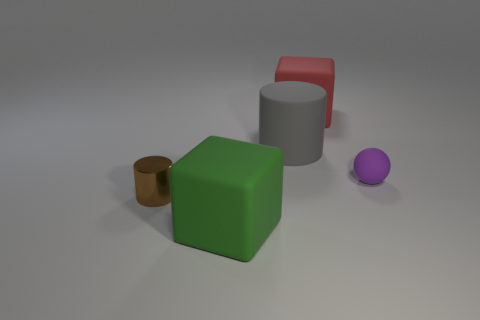Is there anything else that has the same shape as the tiny purple object?
Provide a short and direct response. No. The thing that is both on the right side of the brown object and in front of the tiny purple matte thing is what color?
Give a very brief answer. Green. How many tiny cubes are there?
Your response must be concise. 0. Does the metal object have the same size as the rubber ball?
Ensure brevity in your answer.  Yes. Do the tiny thing left of the large red rubber block and the gray matte object have the same shape?
Ensure brevity in your answer.  Yes. What number of blue rubber things are the same size as the green object?
Offer a very short reply. 0. There is a large object that is right of the matte cylinder; how many big green objects are in front of it?
Your answer should be very brief. 1. Is the material of the tiny ball that is to the right of the tiny brown object the same as the brown cylinder?
Your answer should be compact. No. Do the cylinder left of the large green matte cube and the block right of the large green matte block have the same material?
Offer a very short reply. No. Is the number of cubes that are in front of the big red matte object greater than the number of yellow rubber cubes?
Offer a very short reply. Yes. 